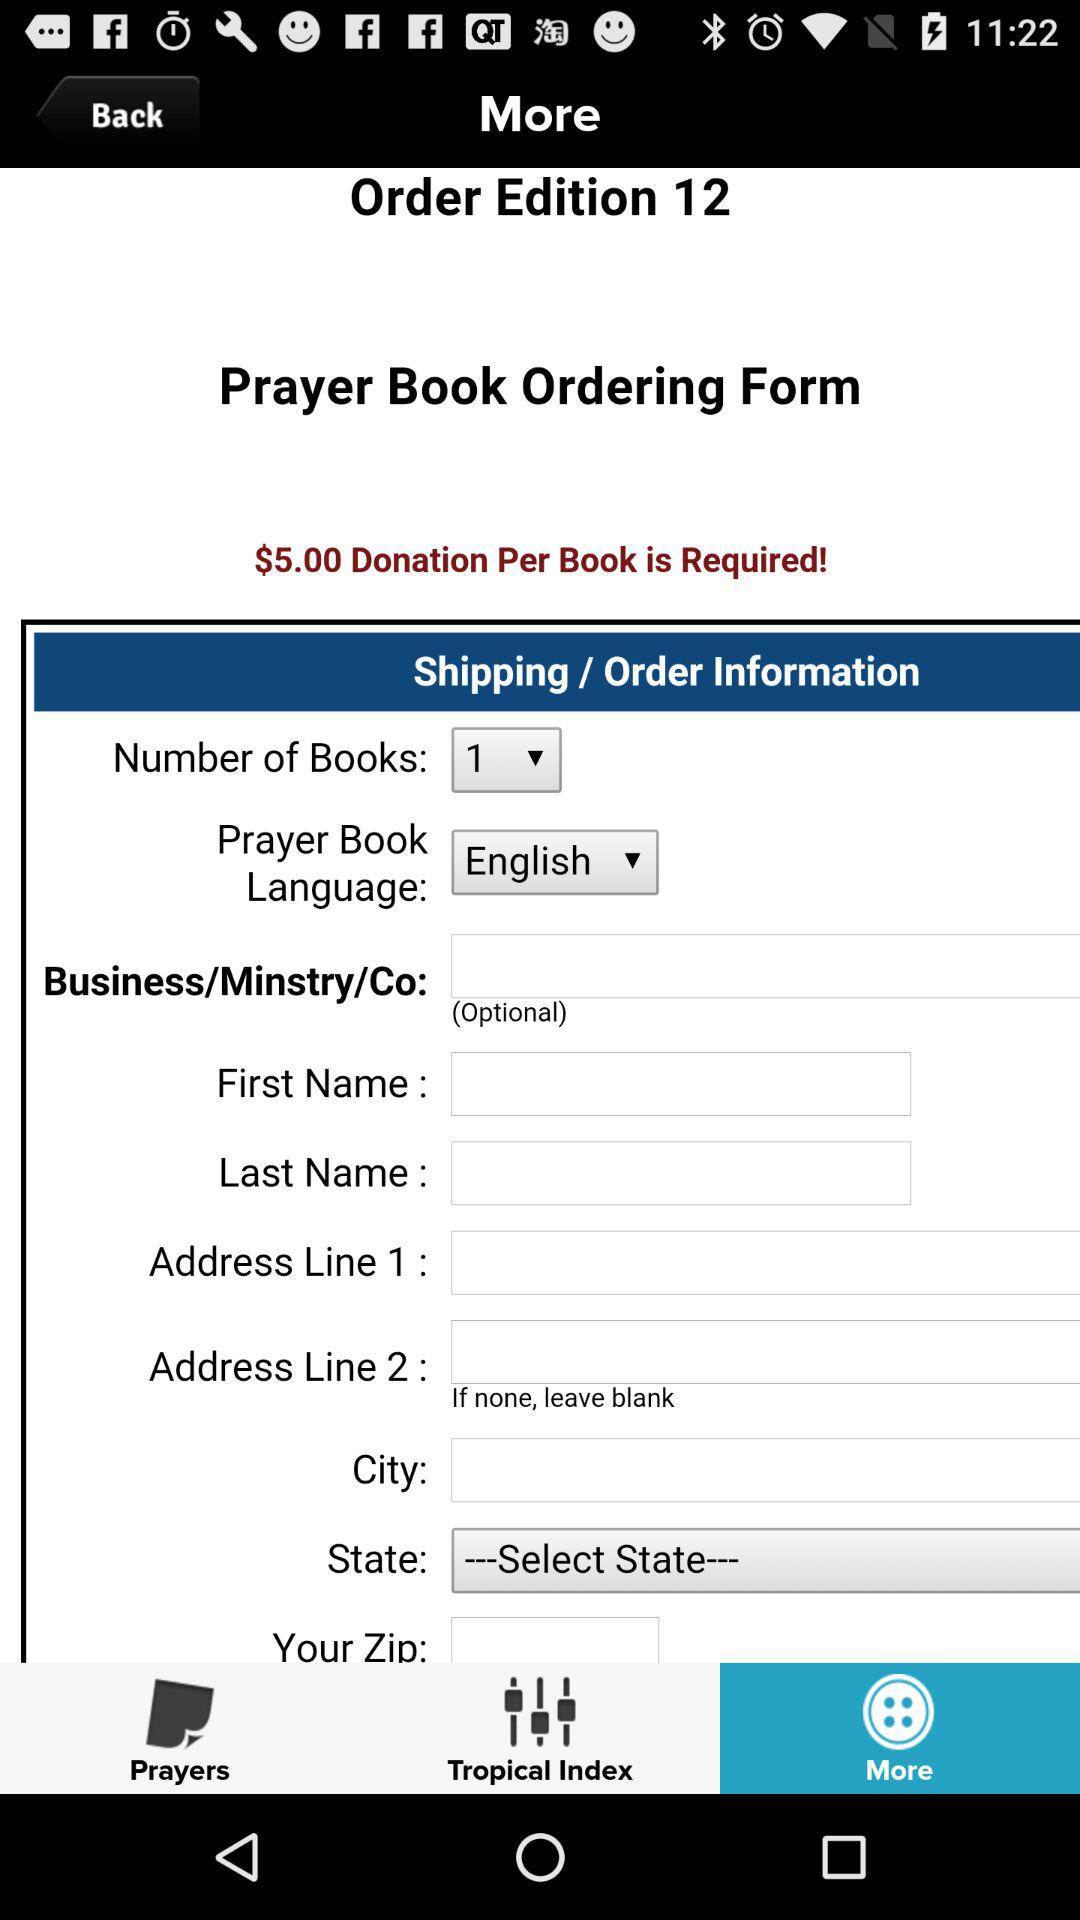How many books are displayed here? The displayed book is 1. 